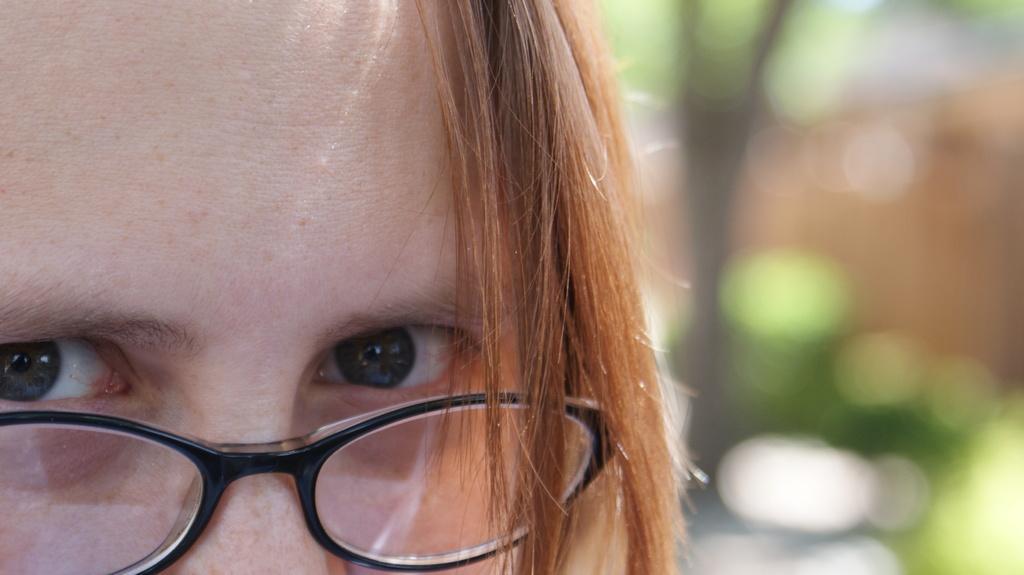Describe this image in one or two sentences. On the left side of this image I can see a person's head having black color spectacles. On the right side the images is blurred. 